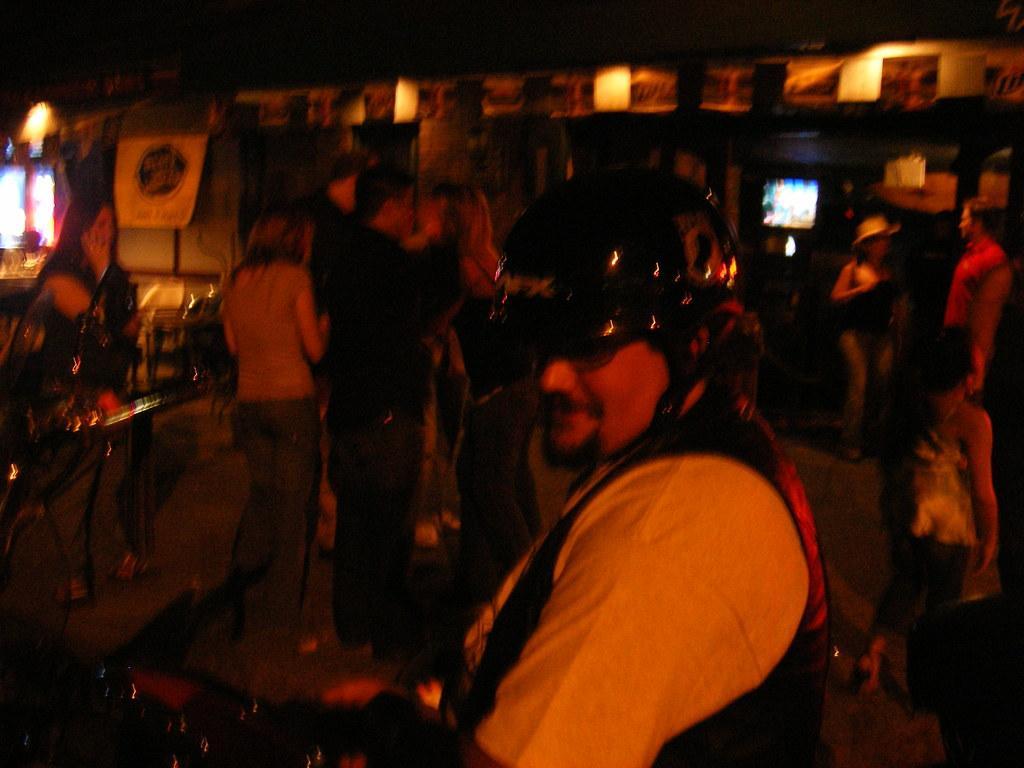Could you give a brief overview of what you see in this image? In this picture there is a man on the right side of the image and there are other people in the background area of the image, there are posters and lights at the top side of the image. 